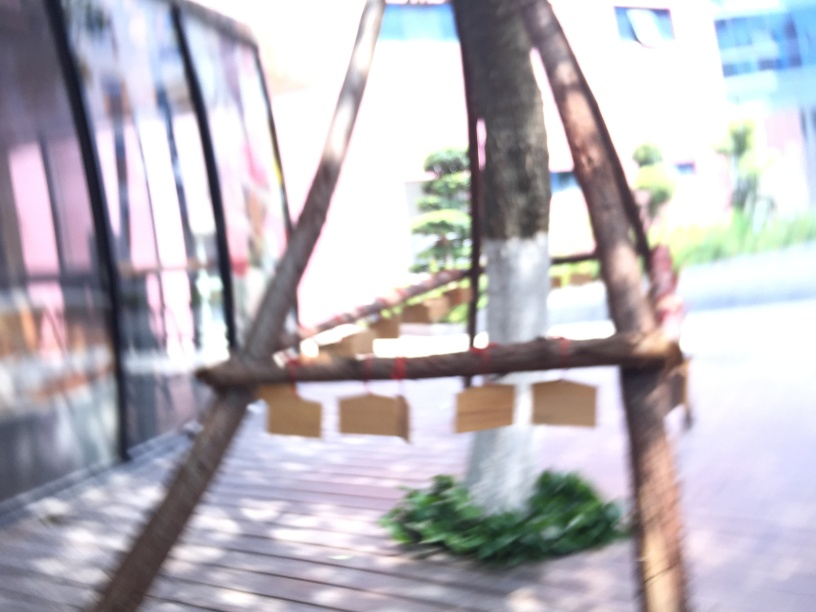How would you describe the composition?
A. Outstanding
B. Impeccable
C. Excellent
D. Poor Given that the image provided is blurry and lacks clear detail, it's difficult to describe the composition in positive terms like outstanding, impeccable, or excellent. As such, the most appropriate description of the composition as it stands would be 'poor' because the focus and clarity are not up to standard photographic quality. 